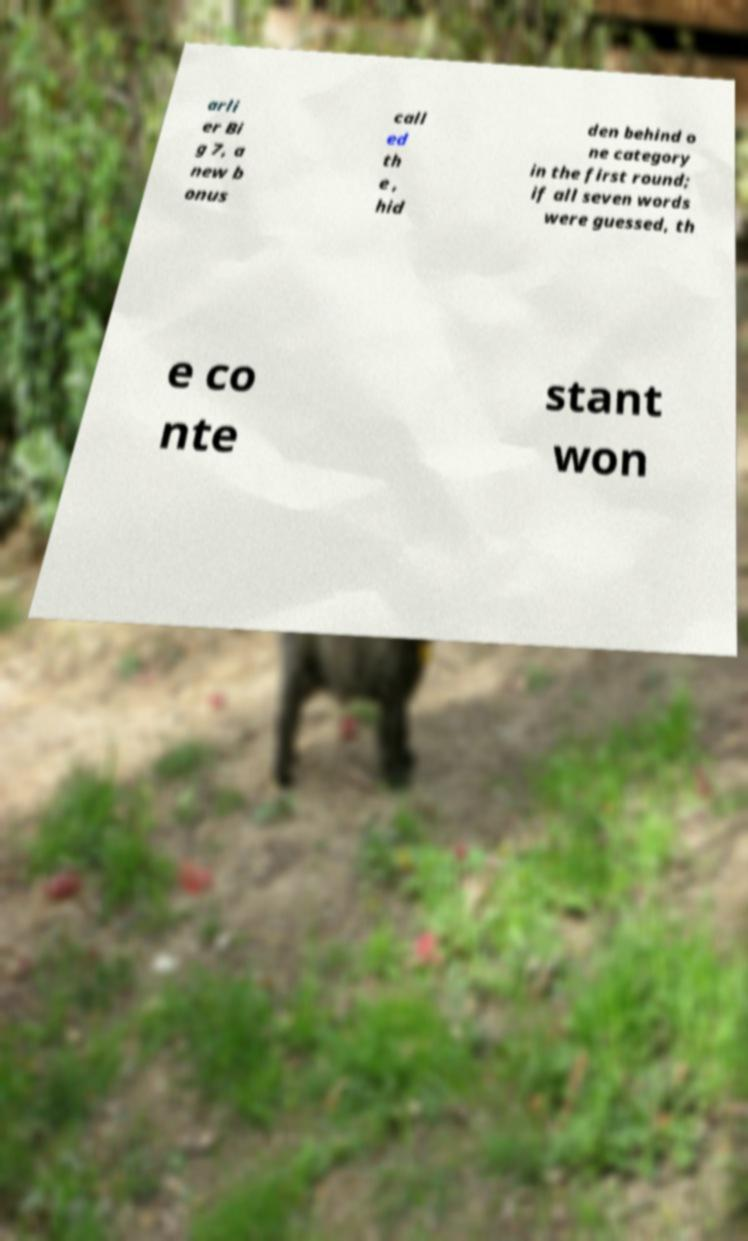Could you assist in decoding the text presented in this image and type it out clearly? arli er Bi g 7, a new b onus call ed th e , hid den behind o ne category in the first round; if all seven words were guessed, th e co nte stant won 